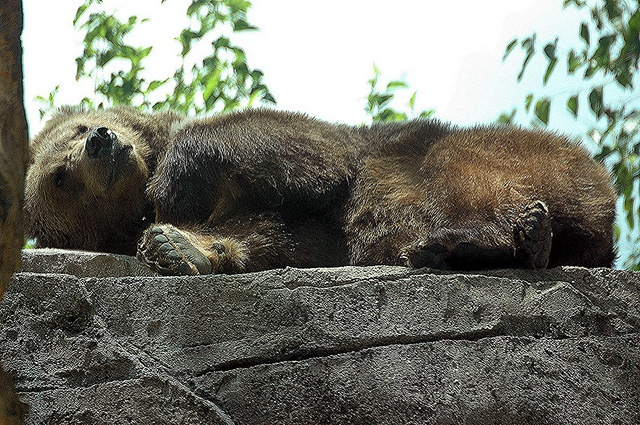Describe the objects in this image and their specific colors. I can see a bear in black and gray tones in this image. 